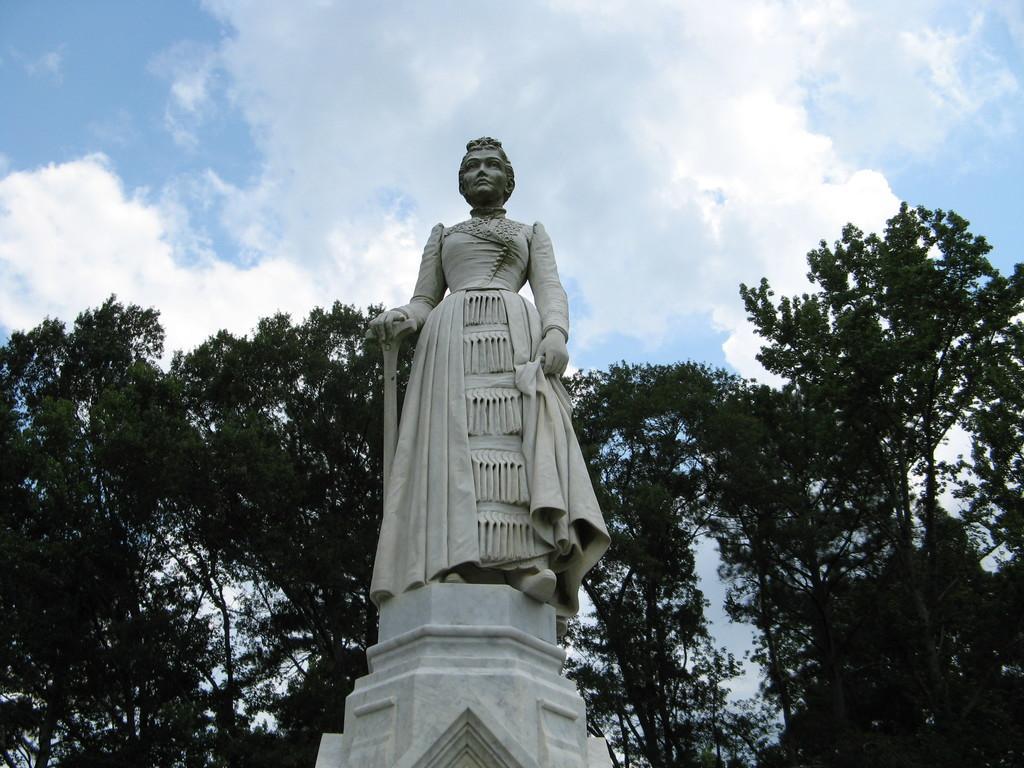In one or two sentences, can you explain what this image depicts? In this picture there is a woman statue placed on the white pillar. Behind there are some trees. Above there is a blue sky and white clouds. 